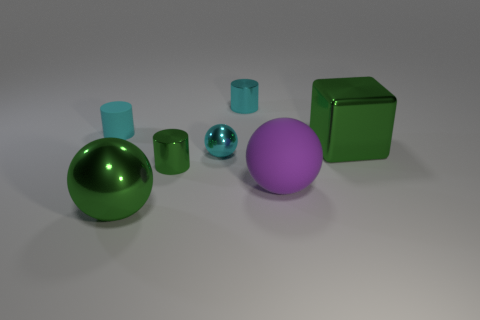Add 3 large blocks. How many objects exist? 10 Subtract all blocks. How many objects are left? 6 Add 1 large green metal balls. How many large green metal balls are left? 2 Add 4 rubber objects. How many rubber objects exist? 6 Subtract 0 yellow blocks. How many objects are left? 7 Subtract all blue cylinders. Subtract all small cyan shiny balls. How many objects are left? 6 